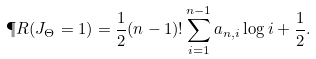Convert formula to latex. <formula><loc_0><loc_0><loc_500><loc_500>\P R ( J _ { \Theta } = 1 ) = \frac { 1 } { 2 } ( n - 1 ) ! \sum _ { i = 1 } ^ { n - 1 } a _ { n , i } \log i + \frac { 1 } { 2 } .</formula> 